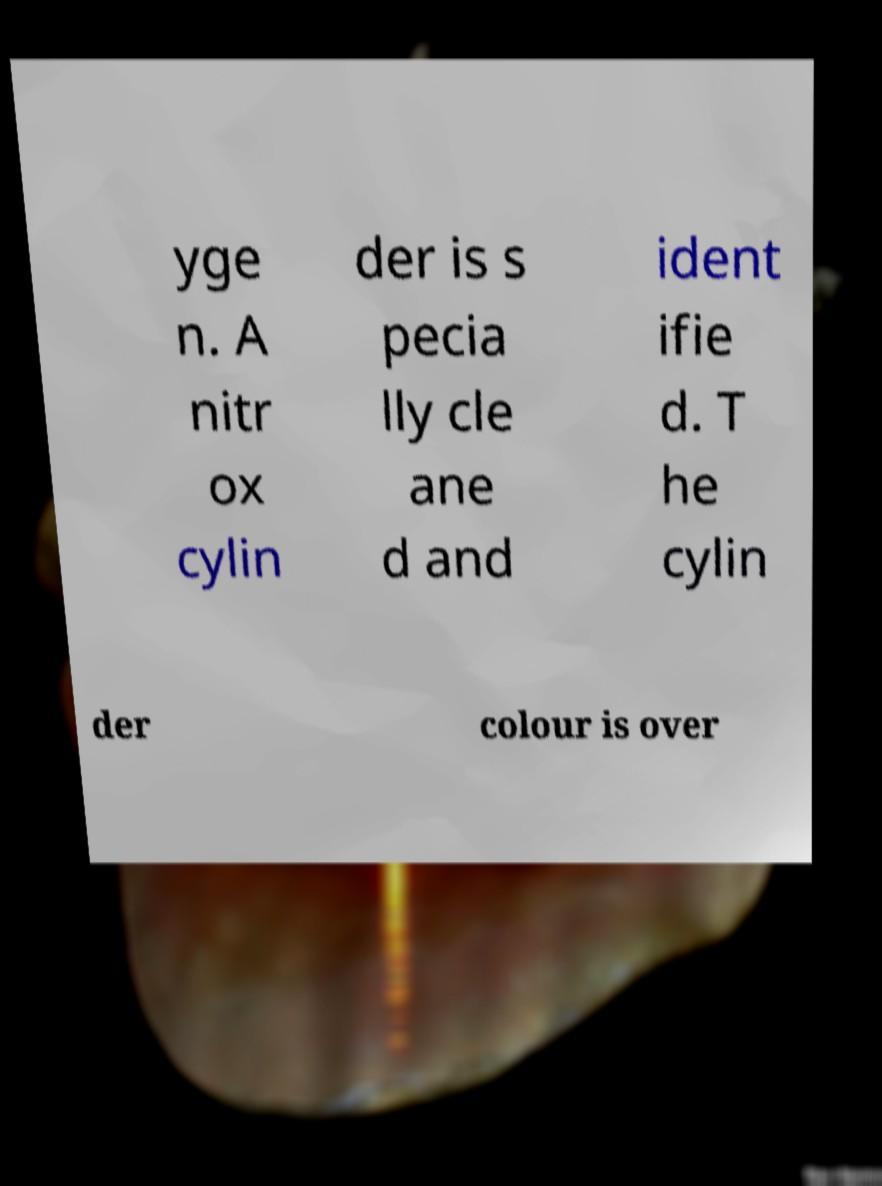For documentation purposes, I need the text within this image transcribed. Could you provide that? yge n. A nitr ox cylin der is s pecia lly cle ane d and ident ifie d. T he cylin der colour is over 